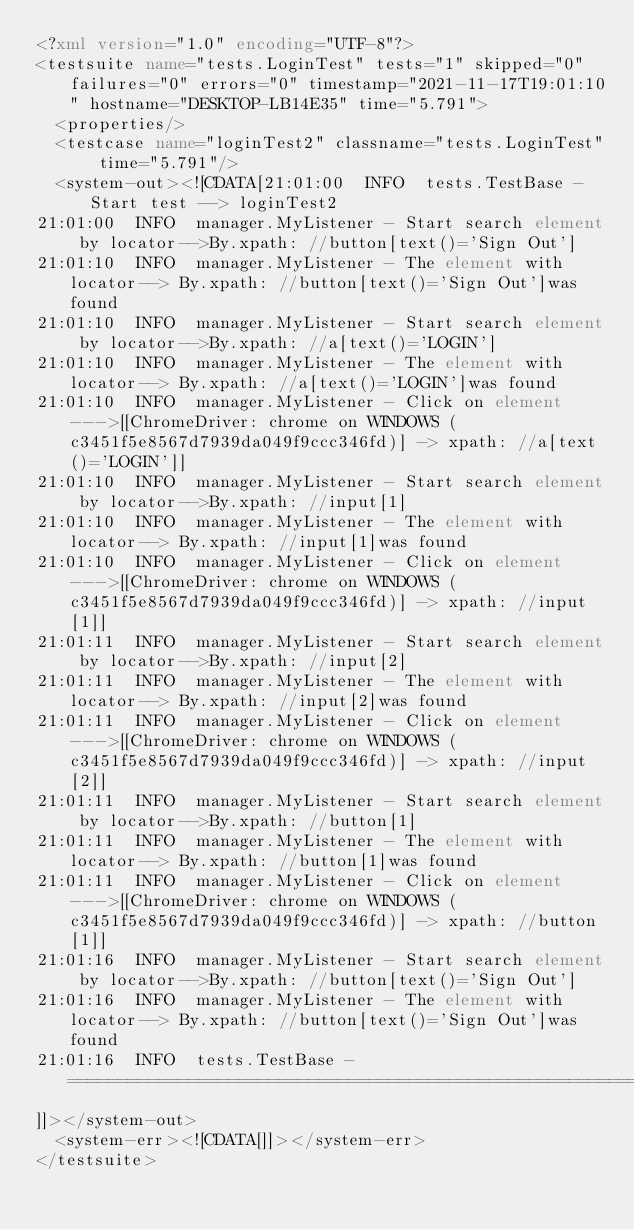Convert code to text. <code><loc_0><loc_0><loc_500><loc_500><_XML_><?xml version="1.0" encoding="UTF-8"?>
<testsuite name="tests.LoginTest" tests="1" skipped="0" failures="0" errors="0" timestamp="2021-11-17T19:01:10" hostname="DESKTOP-LB14E35" time="5.791">
  <properties/>
  <testcase name="loginTest2" classname="tests.LoginTest" time="5.791"/>
  <system-out><![CDATA[21:01:00  INFO  tests.TestBase - Start test --> loginTest2
21:01:00  INFO  manager.MyListener - Start search element by locator-->By.xpath: //button[text()='Sign Out']
21:01:10  INFO  manager.MyListener - The element with locator--> By.xpath: //button[text()='Sign Out']was found
21:01:10  INFO  manager.MyListener - Start search element by locator-->By.xpath: //a[text()='LOGIN']
21:01:10  INFO  manager.MyListener - The element with locator--> By.xpath: //a[text()='LOGIN']was found
21:01:10  INFO  manager.MyListener - Click on element--->[[ChromeDriver: chrome on WINDOWS (c3451f5e8567d7939da049f9ccc346fd)] -> xpath: //a[text()='LOGIN']]
21:01:10  INFO  manager.MyListener - Start search element by locator-->By.xpath: //input[1]
21:01:10  INFO  manager.MyListener - The element with locator--> By.xpath: //input[1]was found
21:01:10  INFO  manager.MyListener - Click on element--->[[ChromeDriver: chrome on WINDOWS (c3451f5e8567d7939da049f9ccc346fd)] -> xpath: //input[1]]
21:01:11  INFO  manager.MyListener - Start search element by locator-->By.xpath: //input[2]
21:01:11  INFO  manager.MyListener - The element with locator--> By.xpath: //input[2]was found
21:01:11  INFO  manager.MyListener - Click on element--->[[ChromeDriver: chrome on WINDOWS (c3451f5e8567d7939da049f9ccc346fd)] -> xpath: //input[2]]
21:01:11  INFO  manager.MyListener - Start search element by locator-->By.xpath: //button[1]
21:01:11  INFO  manager.MyListener - The element with locator--> By.xpath: //button[1]was found
21:01:11  INFO  manager.MyListener - Click on element--->[[ChromeDriver: chrome on WINDOWS (c3451f5e8567d7939da049f9ccc346fd)] -> xpath: //button[1]]
21:01:16  INFO  manager.MyListener - Start search element by locator-->By.xpath: //button[text()='Sign Out']
21:01:16  INFO  manager.MyListener - The element with locator--> By.xpath: //button[text()='Sign Out']was found
21:01:16  INFO  tests.TestBase - ================================================================
]]></system-out>
  <system-err><![CDATA[]]></system-err>
</testsuite>
</code> 